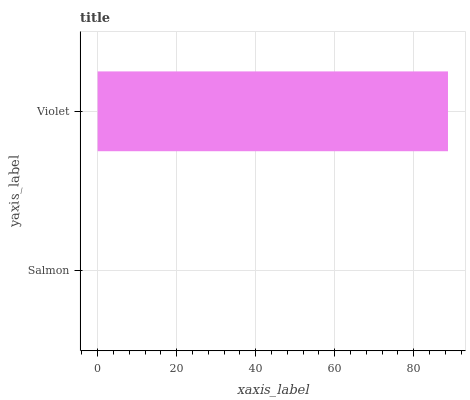Is Salmon the minimum?
Answer yes or no. Yes. Is Violet the maximum?
Answer yes or no. Yes. Is Violet the minimum?
Answer yes or no. No. Is Violet greater than Salmon?
Answer yes or no. Yes. Is Salmon less than Violet?
Answer yes or no. Yes. Is Salmon greater than Violet?
Answer yes or no. No. Is Violet less than Salmon?
Answer yes or no. No. Is Violet the high median?
Answer yes or no. Yes. Is Salmon the low median?
Answer yes or no. Yes. Is Salmon the high median?
Answer yes or no. No. Is Violet the low median?
Answer yes or no. No. 